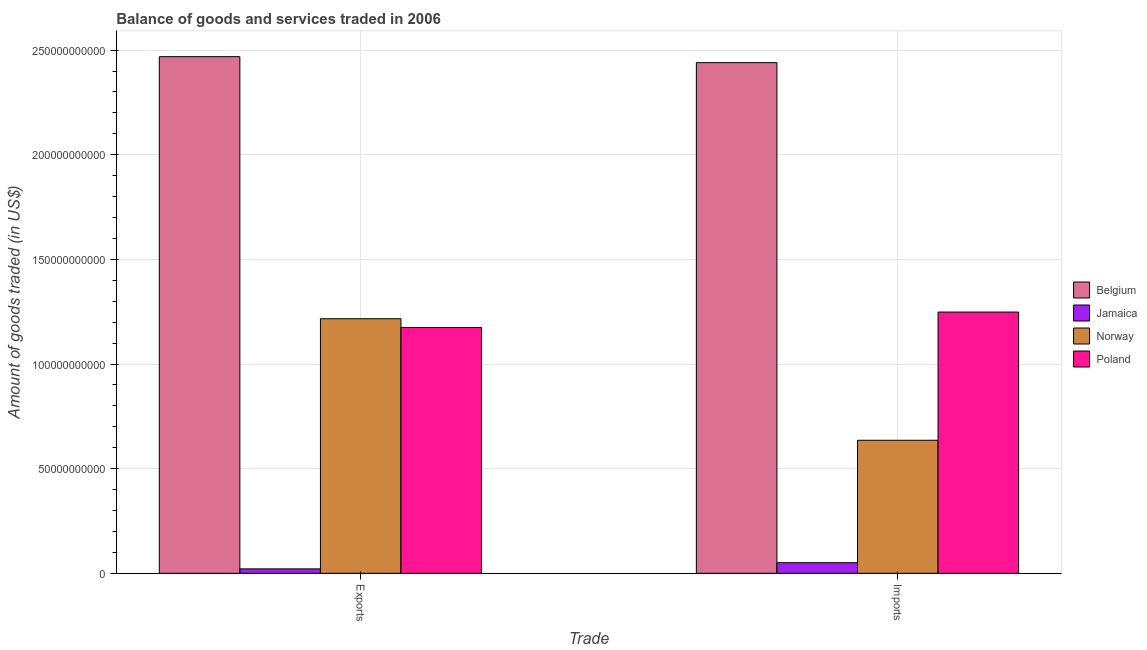How many different coloured bars are there?
Your answer should be compact. 4. How many groups of bars are there?
Provide a succinct answer. 2. Are the number of bars per tick equal to the number of legend labels?
Your answer should be compact. Yes. How many bars are there on the 1st tick from the right?
Make the answer very short. 4. What is the label of the 1st group of bars from the left?
Offer a terse response. Exports. What is the amount of goods imported in Poland?
Make the answer very short. 1.25e+11. Across all countries, what is the maximum amount of goods imported?
Your response must be concise. 2.44e+11. Across all countries, what is the minimum amount of goods exported?
Offer a terse response. 2.13e+09. In which country was the amount of goods imported minimum?
Offer a terse response. Jamaica. What is the total amount of goods exported in the graph?
Provide a short and direct response. 4.88e+11. What is the difference between the amount of goods exported in Belgium and that in Poland?
Offer a very short reply. 1.29e+11. What is the difference between the amount of goods exported in Poland and the amount of goods imported in Jamaica?
Your answer should be very brief. 1.12e+11. What is the average amount of goods imported per country?
Give a very brief answer. 1.09e+11. What is the difference between the amount of goods exported and amount of goods imported in Norway?
Give a very brief answer. 5.81e+1. What is the ratio of the amount of goods exported in Norway to that in Jamaica?
Keep it short and to the point. 57.02. Is the amount of goods imported in Poland less than that in Belgium?
Your answer should be compact. Yes. What does the 4th bar from the right in Exports represents?
Provide a succinct answer. Belgium. How many countries are there in the graph?
Give a very brief answer. 4. Does the graph contain any zero values?
Provide a succinct answer. No. What is the title of the graph?
Offer a terse response. Balance of goods and services traded in 2006. Does "Greece" appear as one of the legend labels in the graph?
Give a very brief answer. No. What is the label or title of the X-axis?
Keep it short and to the point. Trade. What is the label or title of the Y-axis?
Ensure brevity in your answer.  Amount of goods traded (in US$). What is the Amount of goods traded (in US$) in Belgium in Exports?
Provide a short and direct response. 2.47e+11. What is the Amount of goods traded (in US$) of Jamaica in Exports?
Provide a short and direct response. 2.13e+09. What is the Amount of goods traded (in US$) of Norway in Exports?
Your answer should be compact. 1.22e+11. What is the Amount of goods traded (in US$) in Poland in Exports?
Make the answer very short. 1.17e+11. What is the Amount of goods traded (in US$) of Belgium in Imports?
Provide a succinct answer. 2.44e+11. What is the Amount of goods traded (in US$) of Jamaica in Imports?
Keep it short and to the point. 5.08e+09. What is the Amount of goods traded (in US$) of Norway in Imports?
Give a very brief answer. 6.36e+1. What is the Amount of goods traded (in US$) in Poland in Imports?
Your answer should be very brief. 1.25e+11. Across all Trade, what is the maximum Amount of goods traded (in US$) in Belgium?
Provide a succinct answer. 2.47e+11. Across all Trade, what is the maximum Amount of goods traded (in US$) of Jamaica?
Offer a very short reply. 5.08e+09. Across all Trade, what is the maximum Amount of goods traded (in US$) of Norway?
Offer a very short reply. 1.22e+11. Across all Trade, what is the maximum Amount of goods traded (in US$) in Poland?
Your answer should be very brief. 1.25e+11. Across all Trade, what is the minimum Amount of goods traded (in US$) of Belgium?
Make the answer very short. 2.44e+11. Across all Trade, what is the minimum Amount of goods traded (in US$) in Jamaica?
Keep it short and to the point. 2.13e+09. Across all Trade, what is the minimum Amount of goods traded (in US$) of Norway?
Keep it short and to the point. 6.36e+1. Across all Trade, what is the minimum Amount of goods traded (in US$) in Poland?
Ensure brevity in your answer.  1.17e+11. What is the total Amount of goods traded (in US$) in Belgium in the graph?
Offer a terse response. 4.91e+11. What is the total Amount of goods traded (in US$) of Jamaica in the graph?
Provide a succinct answer. 7.21e+09. What is the total Amount of goods traded (in US$) in Norway in the graph?
Make the answer very short. 1.85e+11. What is the total Amount of goods traded (in US$) of Poland in the graph?
Offer a terse response. 2.42e+11. What is the difference between the Amount of goods traded (in US$) of Belgium in Exports and that in Imports?
Ensure brevity in your answer.  2.86e+09. What is the difference between the Amount of goods traded (in US$) in Jamaica in Exports and that in Imports?
Give a very brief answer. -2.94e+09. What is the difference between the Amount of goods traded (in US$) of Norway in Exports and that in Imports?
Keep it short and to the point. 5.81e+1. What is the difference between the Amount of goods traded (in US$) in Poland in Exports and that in Imports?
Ensure brevity in your answer.  -7.39e+09. What is the difference between the Amount of goods traded (in US$) in Belgium in Exports and the Amount of goods traded (in US$) in Jamaica in Imports?
Ensure brevity in your answer.  2.42e+11. What is the difference between the Amount of goods traded (in US$) of Belgium in Exports and the Amount of goods traded (in US$) of Norway in Imports?
Offer a terse response. 1.83e+11. What is the difference between the Amount of goods traded (in US$) in Belgium in Exports and the Amount of goods traded (in US$) in Poland in Imports?
Your answer should be compact. 1.22e+11. What is the difference between the Amount of goods traded (in US$) in Jamaica in Exports and the Amount of goods traded (in US$) in Norway in Imports?
Offer a terse response. -6.14e+1. What is the difference between the Amount of goods traded (in US$) of Jamaica in Exports and the Amount of goods traded (in US$) of Poland in Imports?
Make the answer very short. -1.23e+11. What is the difference between the Amount of goods traded (in US$) of Norway in Exports and the Amount of goods traded (in US$) of Poland in Imports?
Your answer should be compact. -3.18e+09. What is the average Amount of goods traded (in US$) of Belgium per Trade?
Ensure brevity in your answer.  2.45e+11. What is the average Amount of goods traded (in US$) in Jamaica per Trade?
Give a very brief answer. 3.61e+09. What is the average Amount of goods traded (in US$) in Norway per Trade?
Ensure brevity in your answer.  9.26e+1. What is the average Amount of goods traded (in US$) in Poland per Trade?
Offer a very short reply. 1.21e+11. What is the difference between the Amount of goods traded (in US$) of Belgium and Amount of goods traded (in US$) of Jamaica in Exports?
Provide a short and direct response. 2.45e+11. What is the difference between the Amount of goods traded (in US$) in Belgium and Amount of goods traded (in US$) in Norway in Exports?
Your answer should be very brief. 1.25e+11. What is the difference between the Amount of goods traded (in US$) of Belgium and Amount of goods traded (in US$) of Poland in Exports?
Make the answer very short. 1.29e+11. What is the difference between the Amount of goods traded (in US$) in Jamaica and Amount of goods traded (in US$) in Norway in Exports?
Ensure brevity in your answer.  -1.20e+11. What is the difference between the Amount of goods traded (in US$) in Jamaica and Amount of goods traded (in US$) in Poland in Exports?
Provide a short and direct response. -1.15e+11. What is the difference between the Amount of goods traded (in US$) in Norway and Amount of goods traded (in US$) in Poland in Exports?
Give a very brief answer. 4.21e+09. What is the difference between the Amount of goods traded (in US$) of Belgium and Amount of goods traded (in US$) of Jamaica in Imports?
Your answer should be very brief. 2.39e+11. What is the difference between the Amount of goods traded (in US$) in Belgium and Amount of goods traded (in US$) in Norway in Imports?
Ensure brevity in your answer.  1.80e+11. What is the difference between the Amount of goods traded (in US$) in Belgium and Amount of goods traded (in US$) in Poland in Imports?
Give a very brief answer. 1.19e+11. What is the difference between the Amount of goods traded (in US$) in Jamaica and Amount of goods traded (in US$) in Norway in Imports?
Your answer should be very brief. -5.85e+1. What is the difference between the Amount of goods traded (in US$) of Jamaica and Amount of goods traded (in US$) of Poland in Imports?
Your answer should be compact. -1.20e+11. What is the difference between the Amount of goods traded (in US$) of Norway and Amount of goods traded (in US$) of Poland in Imports?
Offer a very short reply. -6.13e+1. What is the ratio of the Amount of goods traded (in US$) in Belgium in Exports to that in Imports?
Your answer should be compact. 1.01. What is the ratio of the Amount of goods traded (in US$) of Jamaica in Exports to that in Imports?
Offer a terse response. 0.42. What is the ratio of the Amount of goods traded (in US$) of Norway in Exports to that in Imports?
Ensure brevity in your answer.  1.91. What is the ratio of the Amount of goods traded (in US$) of Poland in Exports to that in Imports?
Offer a terse response. 0.94. What is the difference between the highest and the second highest Amount of goods traded (in US$) in Belgium?
Make the answer very short. 2.86e+09. What is the difference between the highest and the second highest Amount of goods traded (in US$) in Jamaica?
Offer a terse response. 2.94e+09. What is the difference between the highest and the second highest Amount of goods traded (in US$) in Norway?
Give a very brief answer. 5.81e+1. What is the difference between the highest and the second highest Amount of goods traded (in US$) in Poland?
Offer a terse response. 7.39e+09. What is the difference between the highest and the lowest Amount of goods traded (in US$) of Belgium?
Give a very brief answer. 2.86e+09. What is the difference between the highest and the lowest Amount of goods traded (in US$) of Jamaica?
Give a very brief answer. 2.94e+09. What is the difference between the highest and the lowest Amount of goods traded (in US$) in Norway?
Ensure brevity in your answer.  5.81e+1. What is the difference between the highest and the lowest Amount of goods traded (in US$) of Poland?
Provide a succinct answer. 7.39e+09. 